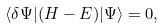<formula> <loc_0><loc_0><loc_500><loc_500>\langle \delta \Psi | ( H - E ) | \Psi \rangle = 0 ,</formula> 